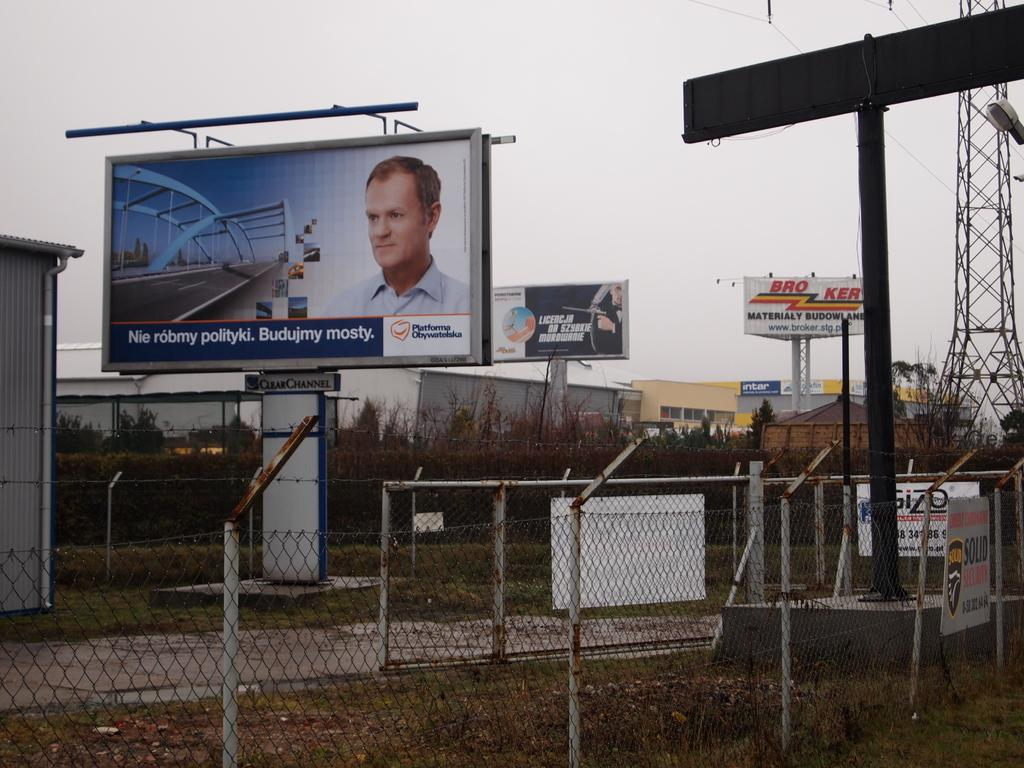<image>
Present a compact description of the photo's key features. a billboard in an industrial zone has the word NIE on it 